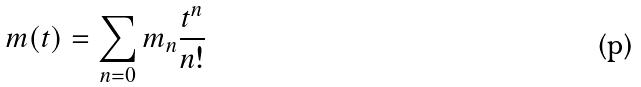<formula> <loc_0><loc_0><loc_500><loc_500>m ( t ) = \sum _ { n = 0 } m _ { n } \frac { t ^ { n } } { n ! }</formula> 